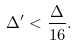Convert formula to latex. <formula><loc_0><loc_0><loc_500><loc_500>\Delta ^ { \prime } < \frac { \Delta } { 1 6 } .</formula> 